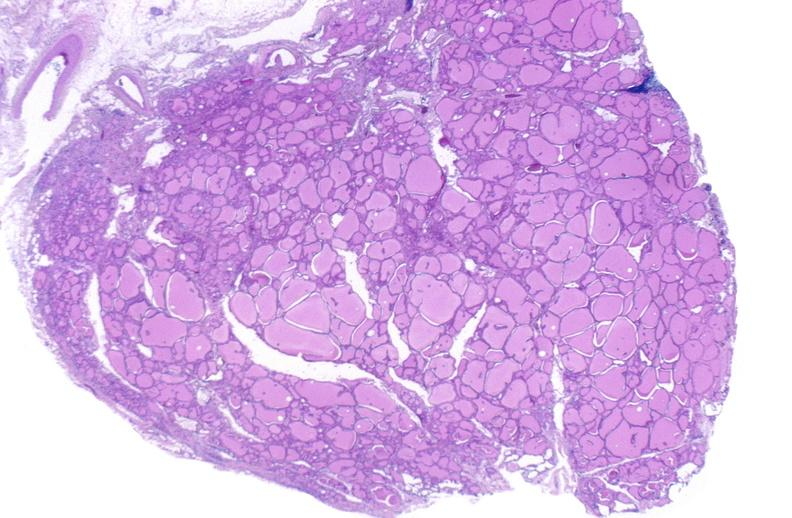s hematoma present?
Answer the question using a single word or phrase. No 